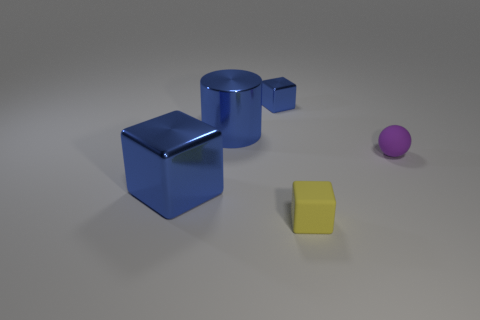What is the big blue thing left of the big blue cylinder made of?
Offer a terse response. Metal. The block that is both left of the tiny yellow thing and in front of the small metallic cube is what color?
Your answer should be compact. Blue. How many other objects are there of the same color as the small matte block?
Offer a very short reply. 0. What is the color of the shiny cube that is in front of the small blue metallic block?
Your answer should be compact. Blue. Is there a matte block that has the same size as the purple rubber ball?
Make the answer very short. Yes. What material is the blue thing that is the same size as the matte ball?
Ensure brevity in your answer.  Metal. How many things are either blue cylinders that are behind the tiny yellow rubber block or cubes behind the purple object?
Your answer should be compact. 2. Is there a small yellow rubber thing of the same shape as the small blue shiny thing?
Your answer should be very brief. Yes. How many matte objects are either cubes or small red balls?
Provide a short and direct response. 1. There is a purple matte object; what shape is it?
Offer a terse response. Sphere. 